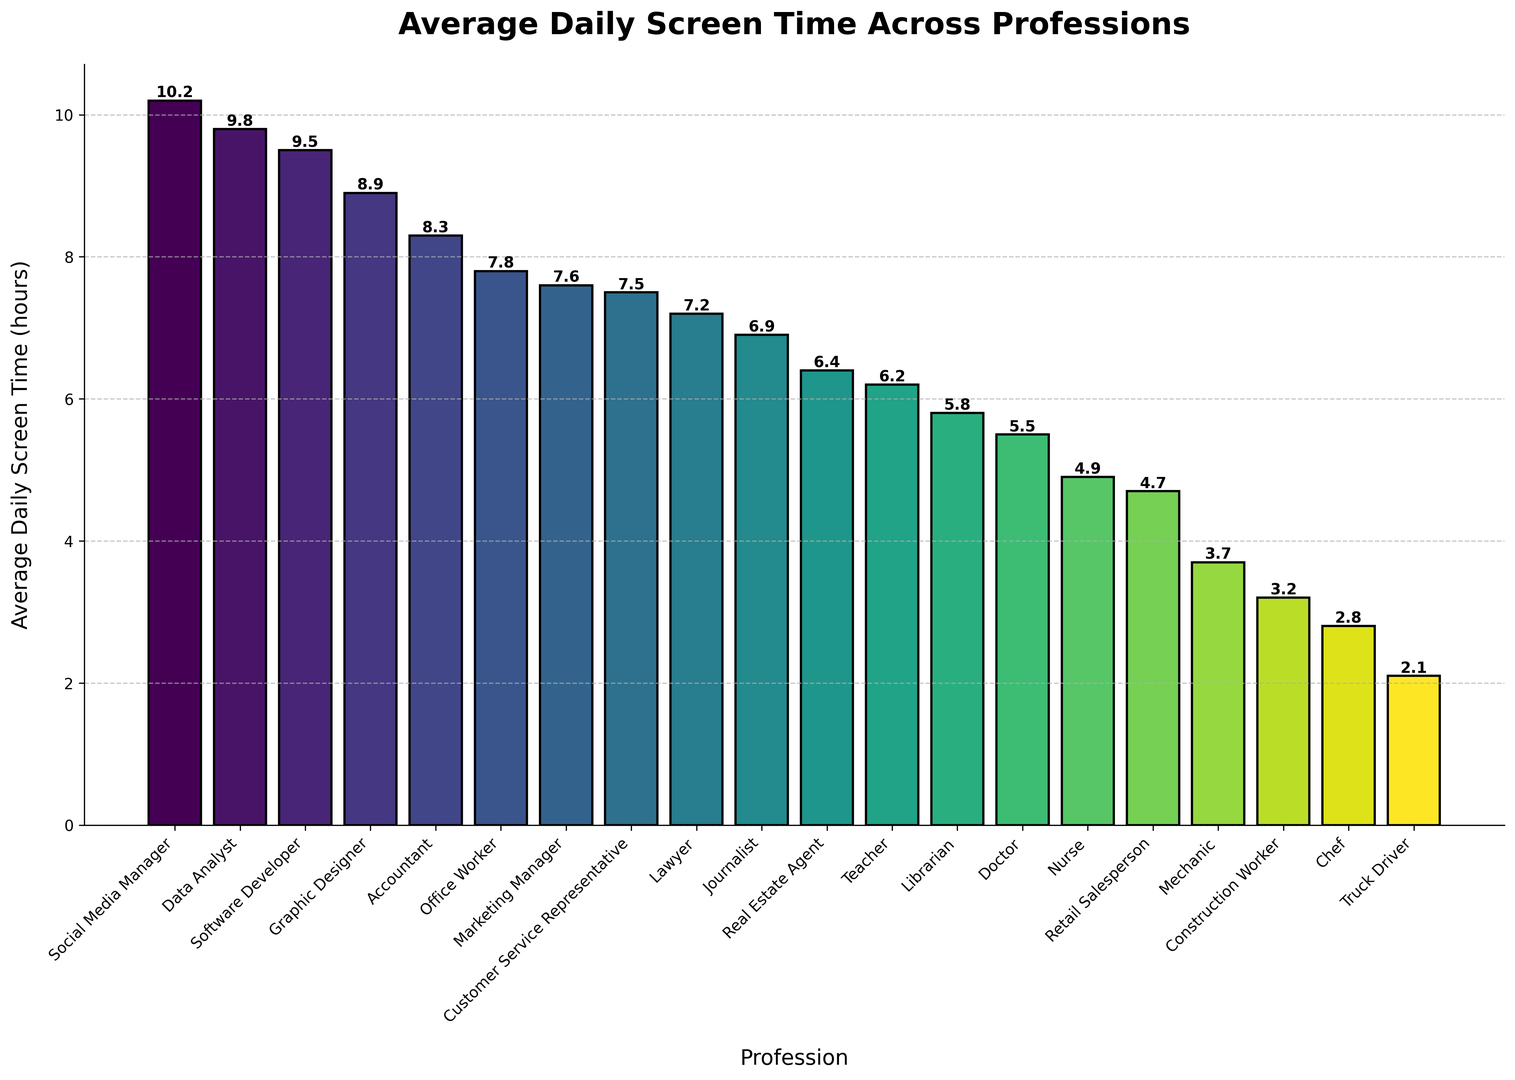What's the profession with the highest average daily screen time? To find out who has the highest average daily screen time, look for the tallest bar in the chart. In this case, it's the bar for Social Media Manager.
Answer: Social Media Manager Which profession spends less time on screens: Teacher or Lawyer? Compare the heights of the bars for Teacher and Lawyer. The Teacher's average daily screen time is lower than that of the Lawyer.
Answer: Teacher How much more screen time do Software Developers have compared to Doctors? Find the bars for Software Developer and Doctor. The Software Developer has 9.5 hours, and the Doctor has 5.5 hours. Subtract 5.5 from 9.5 to get the difference.
Answer: 4.0 hours What is the combined average daily screen time for Nurses and Mechanics? Sum the average daily screen time of Nurses (4.9) and Mechanics (3.7). Adding these values: 4.9 + 3.7 = 8.6 hours.
Answer: 8.6 hours Which profession has the lowest average daily screen time and how many hours is it? Identify the shortest bar in the chart, which corresponds to Truck Driver, and note the value.
Answer: Truck Driver, 2.1 hours What's the range of average daily screen times depicted in the chart? The range is calculated by subtracting the smallest value (Truck Driver, 2.1 hours) from the largest value (Social Media Manager, 10.2 hours). 10.2 - 2.1 = 8.1 hours.
Answer: 8.1 hours How much screen time do Marketing Managers have compared to Office Workers? Locate the bars for Marketing Manager (7.6 hours) and Office Worker (7.8 hours) and subtract the smaller value from the larger value.
Answer: 0.2 hours less Among Data Analysts, Accountants, and Graphic Designers, who spends an average of the most time on screens? Compare the bars for Data Analyst (9.8 hours), Accountant (8.3 hours), and Graphic Designer (8.9 hours). The highest value is for Data Analyst.
Answer: Data Analyst What is the average screen time for professions with more than 7 hours (Software Developer, Office Worker, Graphic Designer, Accountant, Marketing Manager, Social Media Manager, Data Analyst)? Sum the screen time for each of these professions (9.5 + 7.8 + 8.9 + 8.3 + 7.6 + 10.2 + 9.8) to get the total, then divide by the number of professions (7). (62.1 / 7)
Answer: 8.87 hours 